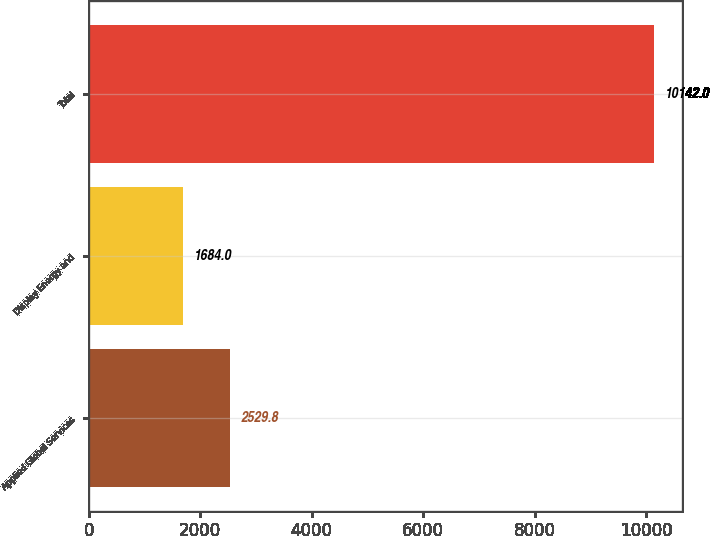Convert chart to OTSL. <chart><loc_0><loc_0><loc_500><loc_500><bar_chart><fcel>Applied Global Services<fcel>Display Energy and<fcel>Total<nl><fcel>2529.8<fcel>1684<fcel>10142<nl></chart> 